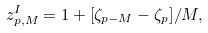Convert formula to latex. <formula><loc_0><loc_0><loc_500><loc_500>z ^ { I } _ { p , M } = 1 + [ \zeta _ { p - M } - \zeta _ { p } ] / M ,</formula> 